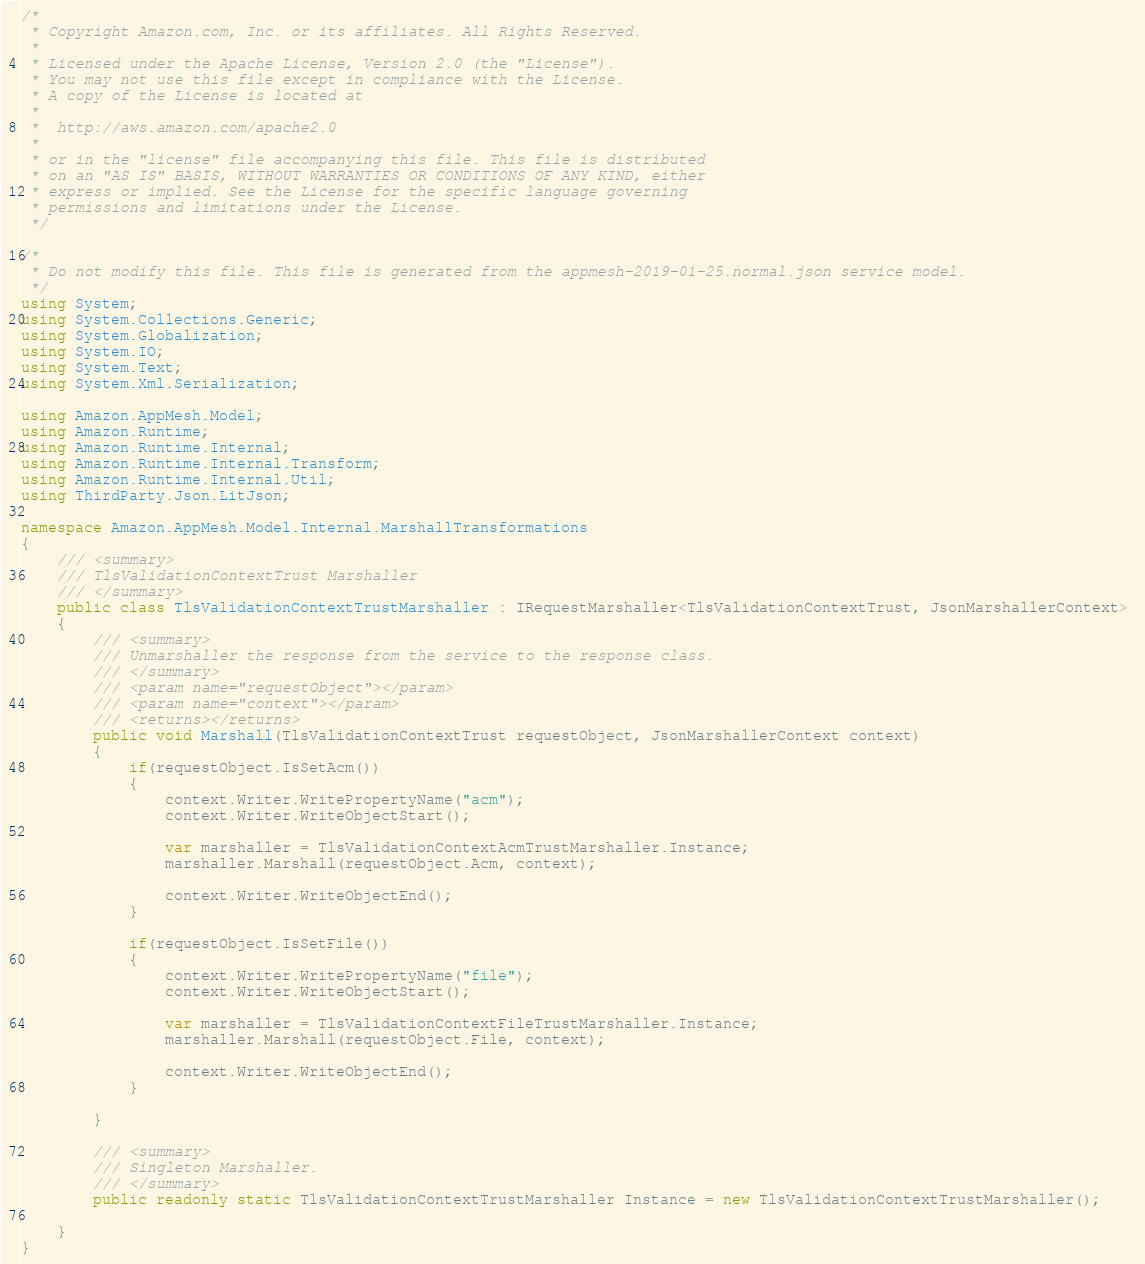Convert code to text. <code><loc_0><loc_0><loc_500><loc_500><_C#_>/*
 * Copyright Amazon.com, Inc. or its affiliates. All Rights Reserved.
 * 
 * Licensed under the Apache License, Version 2.0 (the "License").
 * You may not use this file except in compliance with the License.
 * A copy of the License is located at
 * 
 *  http://aws.amazon.com/apache2.0
 * 
 * or in the "license" file accompanying this file. This file is distributed
 * on an "AS IS" BASIS, WITHOUT WARRANTIES OR CONDITIONS OF ANY KIND, either
 * express or implied. See the License for the specific language governing
 * permissions and limitations under the License.
 */

/*
 * Do not modify this file. This file is generated from the appmesh-2019-01-25.normal.json service model.
 */
using System;
using System.Collections.Generic;
using System.Globalization;
using System.IO;
using System.Text;
using System.Xml.Serialization;

using Amazon.AppMesh.Model;
using Amazon.Runtime;
using Amazon.Runtime.Internal;
using Amazon.Runtime.Internal.Transform;
using Amazon.Runtime.Internal.Util;
using ThirdParty.Json.LitJson;

namespace Amazon.AppMesh.Model.Internal.MarshallTransformations
{
    /// <summary>
    /// TlsValidationContextTrust Marshaller
    /// </summary>       
    public class TlsValidationContextTrustMarshaller : IRequestMarshaller<TlsValidationContextTrust, JsonMarshallerContext> 
    {
        /// <summary>
        /// Unmarshaller the response from the service to the response class.
        /// </summary>  
        /// <param name="requestObject"></param>
        /// <param name="context"></param>
        /// <returns></returns>
        public void Marshall(TlsValidationContextTrust requestObject, JsonMarshallerContext context)
        {
            if(requestObject.IsSetAcm())
            {
                context.Writer.WritePropertyName("acm");
                context.Writer.WriteObjectStart();

                var marshaller = TlsValidationContextAcmTrustMarshaller.Instance;
                marshaller.Marshall(requestObject.Acm, context);

                context.Writer.WriteObjectEnd();
            }

            if(requestObject.IsSetFile())
            {
                context.Writer.WritePropertyName("file");
                context.Writer.WriteObjectStart();

                var marshaller = TlsValidationContextFileTrustMarshaller.Instance;
                marshaller.Marshall(requestObject.File, context);

                context.Writer.WriteObjectEnd();
            }

        }

        /// <summary>
        /// Singleton Marshaller.
        /// </summary>  
        public readonly static TlsValidationContextTrustMarshaller Instance = new TlsValidationContextTrustMarshaller();

    }
}</code> 